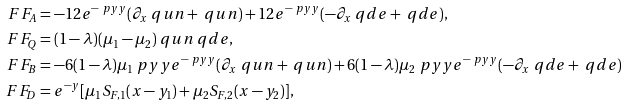<formula> <loc_0><loc_0><loc_500><loc_500>\ F F _ { A } & = - 1 2 e ^ { - \ p y y } ( \partial _ { x } \ q u n + \ q u n ) + 1 2 e ^ { - \ p y y } ( - \partial _ { x } \ q d e + \ q d e ) , \\ \ F F _ { Q } & = ( 1 - \lambda ) ( \mu _ { 1 } - \mu _ { 2 } ) \ q u n \ q d e , \\ \ F F _ { B } & = - 6 ( 1 - \lambda ) \mu _ { 1 } \ p y y e ^ { - \ p y y } ( \partial _ { x } \ q u n + \ q u n ) + 6 ( 1 - \lambda ) \mu _ { 2 } \ p y y e ^ { - \ p y y } ( - \partial _ { x } \ q d e + \ q d e ) \\ \ F F _ { D } & = e ^ { - y } [ \mu _ { 1 } S _ { F , 1 } ( x - y _ { 1 } ) + \mu _ { 2 } S _ { F , 2 } ( x - y _ { 2 } ) ] ,</formula> 